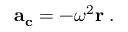Convert formula to latex. <formula><loc_0><loc_0><loc_500><loc_500>a _ { c } = - \omega ^ { 2 } r \, .</formula> 